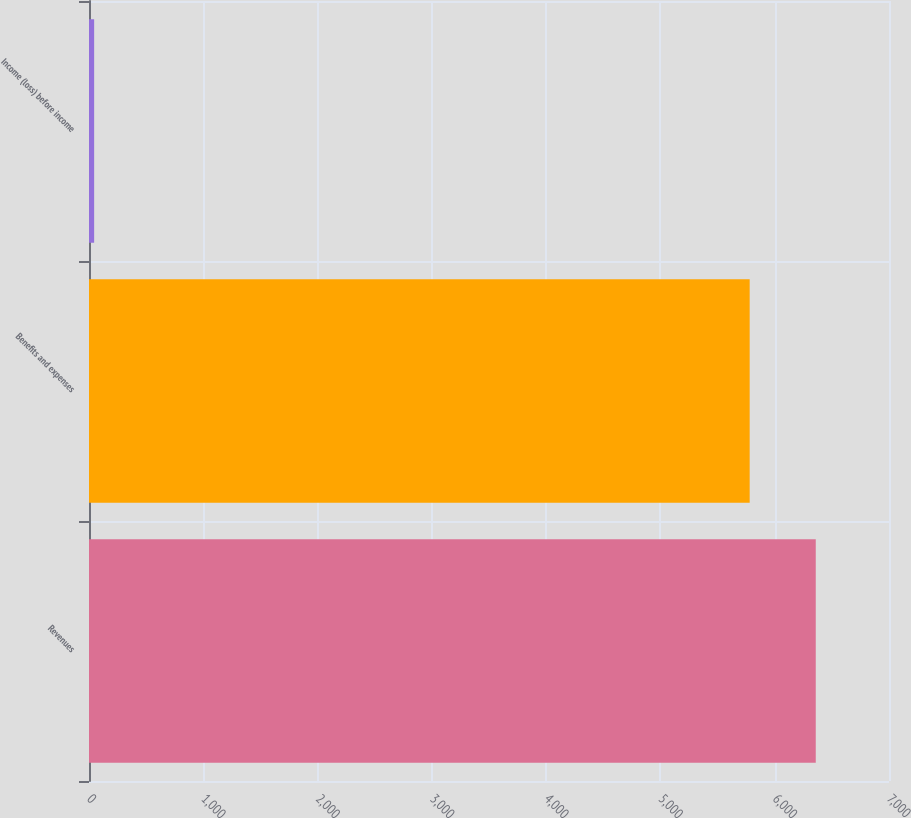Convert chart to OTSL. <chart><loc_0><loc_0><loc_500><loc_500><bar_chart><fcel>Revenues<fcel>Benefits and expenses<fcel>Income (loss) before income<nl><fcel>6359.1<fcel>5781<fcel>45<nl></chart> 